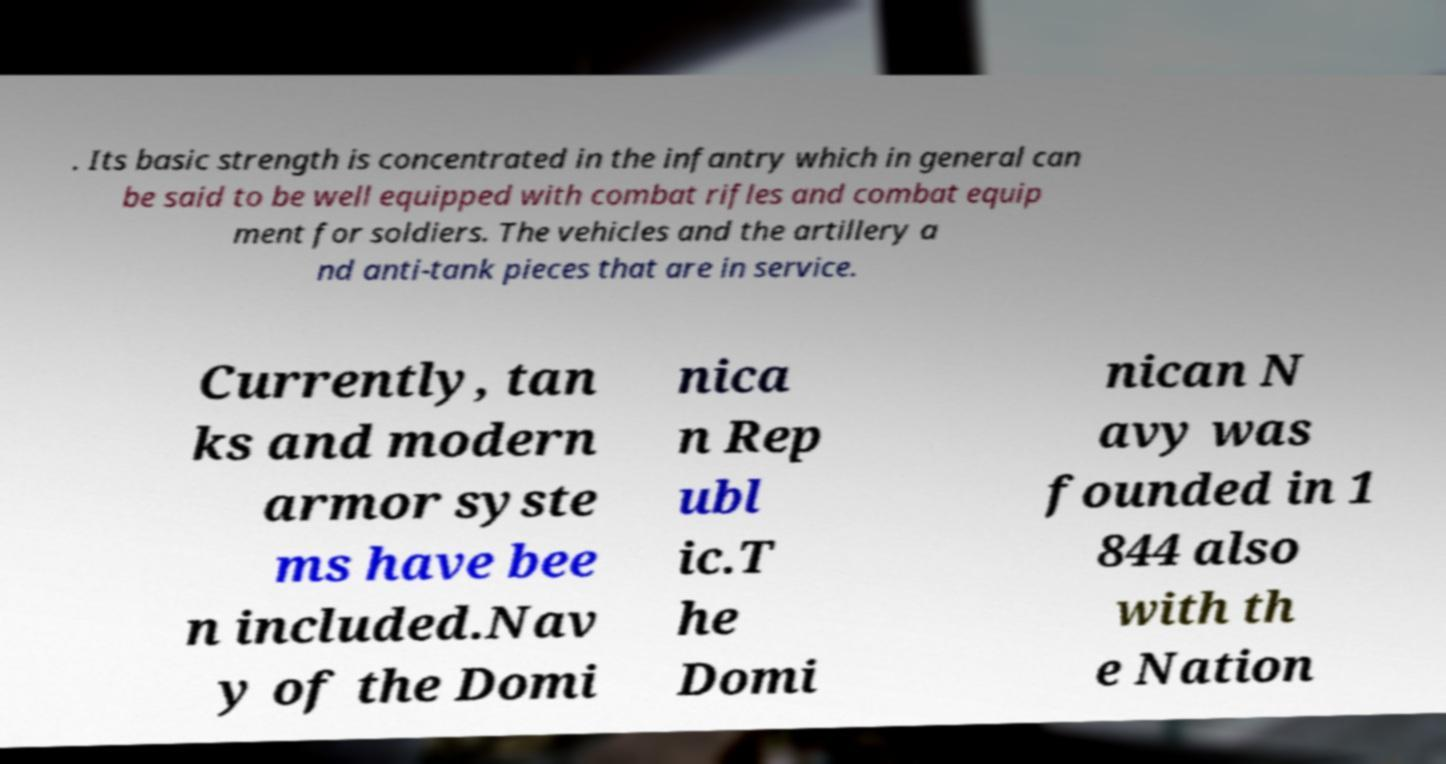For documentation purposes, I need the text within this image transcribed. Could you provide that? . Its basic strength is concentrated in the infantry which in general can be said to be well equipped with combat rifles and combat equip ment for soldiers. The vehicles and the artillery a nd anti-tank pieces that are in service. Currently, tan ks and modern armor syste ms have bee n included.Nav y of the Domi nica n Rep ubl ic.T he Domi nican N avy was founded in 1 844 also with th e Nation 